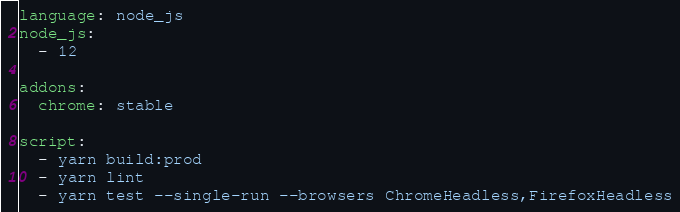Convert code to text. <code><loc_0><loc_0><loc_500><loc_500><_YAML_>language: node_js
node_js:
  - 12

addons:
  chrome: stable

script:
  - yarn build:prod
  - yarn lint
  - yarn test --single-run --browsers ChromeHeadless,FirefoxHeadless
</code> 